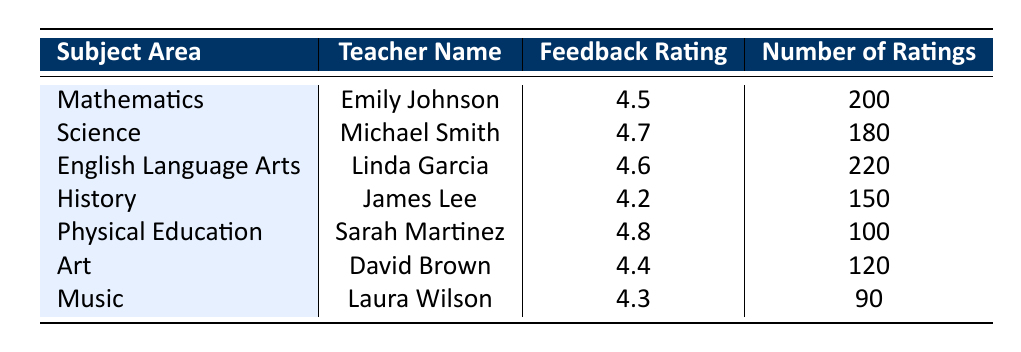What is the feedback rating for Physical Education? The table shows that the Feedback Rating for Physical Education is listed next to Sarah Martinez's name. Referring to that cell gives the value of 4.8.
Answer: 4.8 Who has the highest feedback rating among the teachers? By comparing the Feedback Ratings in the table, Michael Smith has the highest rating of 4.7, which is higher than all other teachers' ratings.
Answer: Michael Smith What is the total number of ratings received by all subjects combined? To find the total number of ratings, we add up the Number of Ratings for each subject: 200 (Math) + 180 (Science) + 220 (English) + 150 (History) + 100 (PE) + 120 (Art) + 90 (Music) = 1060.
Answer: 1060 Is the feedback rating for Art higher than that for History? The Feedback Rating for Art (4.4) can be compared with the Feedback Rating for History (4.2). Since 4.4 is greater than 4.2, the statement is true.
Answer: Yes What is the average feedback rating of all the teachers listed? First, sum the feedback ratings: 4.5 (Math) + 4.7 (Science) + 4.6 (English) + 4.2 (History) + 4.8 (PE) + 4.4 (Art) + 4.3 (Music) = 28.5. Then, divide that sum by the number of subjects (7) to find the average: 28.5 / 7 = approximately 4.07.
Answer: 4.07 Which subject area has the lowest feedback rating and what is that rating? Looking at the Feedback Ratings, History has the lowest rating at 4.2, which is lower than all other subjects' ratings.
Answer: History, 4.2 Are there more total feedback ratings for English Language Arts than Physical Education? English Language Arts has 220 ratings while Physical Education has 100 ratings. Since 220 is greater than 100, it is true that English has more ratings.
Answer: Yes What is the difference in the number of ratings between Science and Music? The Number of Ratings for Science is 180 and for Music, it is 90. To find the difference, subtract Music's ratings from Science's: 180 - 90 = 90.
Answer: 90 